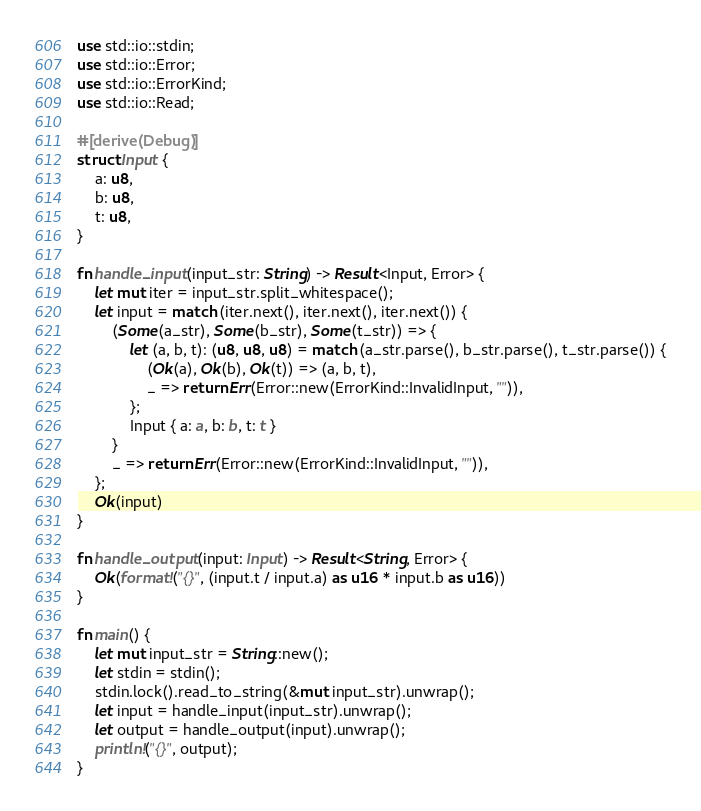Convert code to text. <code><loc_0><loc_0><loc_500><loc_500><_Rust_>use std::io::stdin;
use std::io::Error;
use std::io::ErrorKind;
use std::io::Read;

#[derive(Debug)]
struct Input {
    a: u8,
    b: u8,
    t: u8,
}

fn handle_input(input_str: String) -> Result<Input, Error> {
    let mut iter = input_str.split_whitespace();
    let input = match (iter.next(), iter.next(), iter.next()) {
        (Some(a_str), Some(b_str), Some(t_str)) => {
            let (a, b, t): (u8, u8, u8) = match (a_str.parse(), b_str.parse(), t_str.parse()) {
                (Ok(a), Ok(b), Ok(t)) => (a, b, t),
                _ => return Err(Error::new(ErrorKind::InvalidInput, "")),
            };
            Input { a: a, b: b, t: t }
        }
        _ => return Err(Error::new(ErrorKind::InvalidInput, "")),
    };
    Ok(input)
}

fn handle_output(input: Input) -> Result<String, Error> {
    Ok(format!("{}", (input.t / input.a) as u16 * input.b as u16))
}

fn main() {
    let mut input_str = String::new();
    let stdin = stdin();
    stdin.lock().read_to_string(&mut input_str).unwrap();
    let input = handle_input(input_str).unwrap();
    let output = handle_output(input).unwrap();
    println!("{}", output);
}</code> 